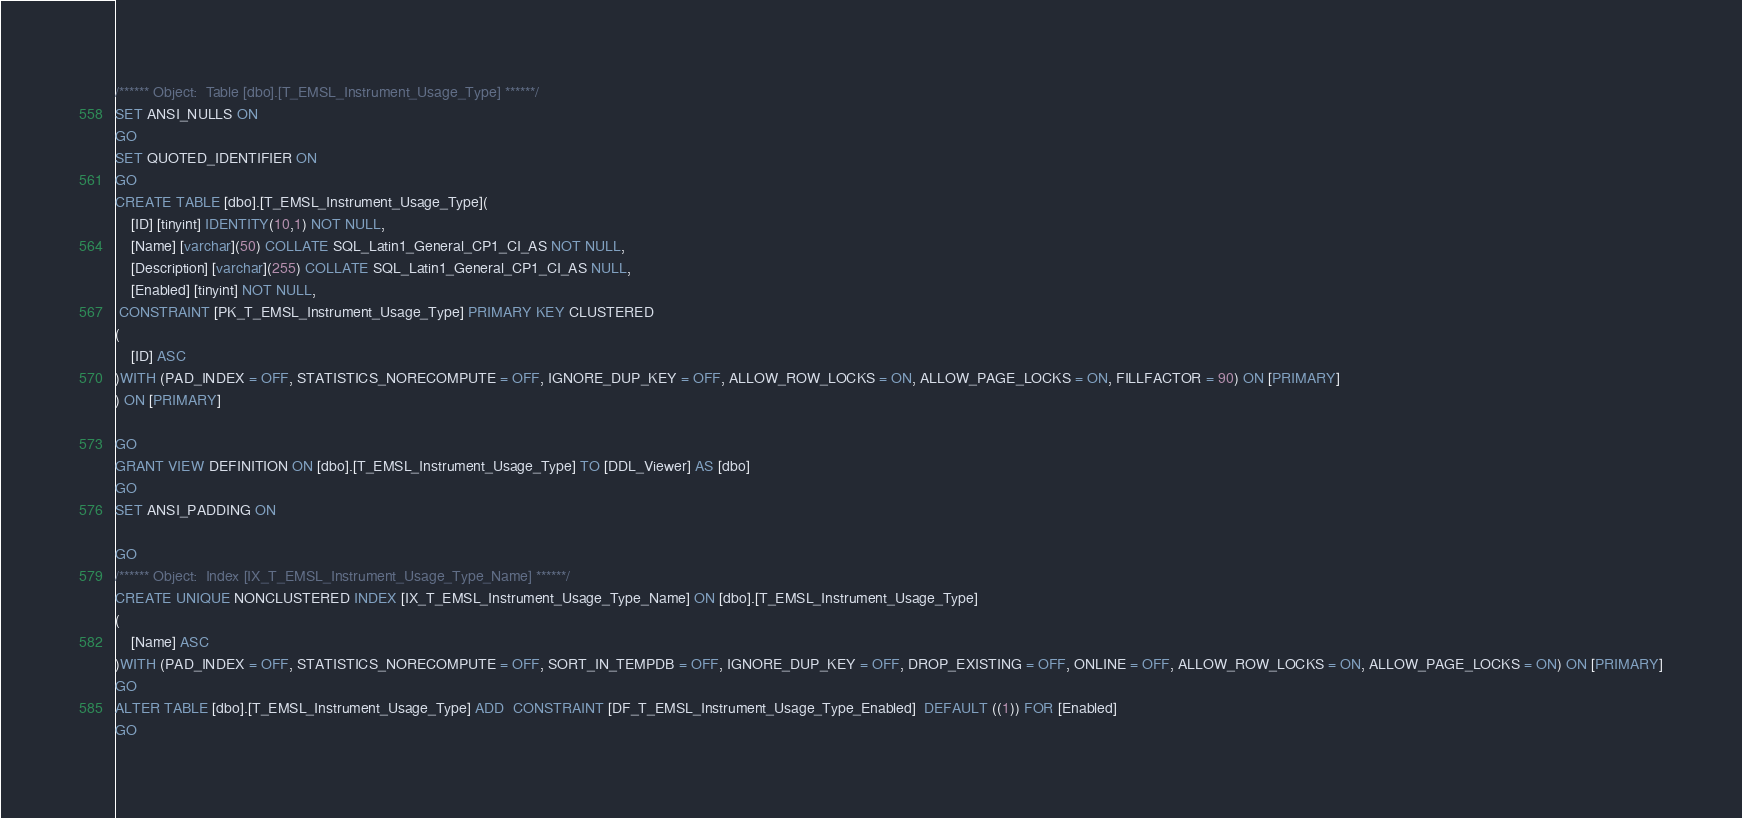Convert code to text. <code><loc_0><loc_0><loc_500><loc_500><_SQL_>/****** Object:  Table [dbo].[T_EMSL_Instrument_Usage_Type] ******/
SET ANSI_NULLS ON
GO
SET QUOTED_IDENTIFIER ON
GO
CREATE TABLE [dbo].[T_EMSL_Instrument_Usage_Type](
	[ID] [tinyint] IDENTITY(10,1) NOT NULL,
	[Name] [varchar](50) COLLATE SQL_Latin1_General_CP1_CI_AS NOT NULL,
	[Description] [varchar](255) COLLATE SQL_Latin1_General_CP1_CI_AS NULL,
	[Enabled] [tinyint] NOT NULL,
 CONSTRAINT [PK_T_EMSL_Instrument_Usage_Type] PRIMARY KEY CLUSTERED 
(
	[ID] ASC
)WITH (PAD_INDEX = OFF, STATISTICS_NORECOMPUTE = OFF, IGNORE_DUP_KEY = OFF, ALLOW_ROW_LOCKS = ON, ALLOW_PAGE_LOCKS = ON, FILLFACTOR = 90) ON [PRIMARY]
) ON [PRIMARY]

GO
GRANT VIEW DEFINITION ON [dbo].[T_EMSL_Instrument_Usage_Type] TO [DDL_Viewer] AS [dbo]
GO
SET ANSI_PADDING ON

GO
/****** Object:  Index [IX_T_EMSL_Instrument_Usage_Type_Name] ******/
CREATE UNIQUE NONCLUSTERED INDEX [IX_T_EMSL_Instrument_Usage_Type_Name] ON [dbo].[T_EMSL_Instrument_Usage_Type]
(
	[Name] ASC
)WITH (PAD_INDEX = OFF, STATISTICS_NORECOMPUTE = OFF, SORT_IN_TEMPDB = OFF, IGNORE_DUP_KEY = OFF, DROP_EXISTING = OFF, ONLINE = OFF, ALLOW_ROW_LOCKS = ON, ALLOW_PAGE_LOCKS = ON) ON [PRIMARY]
GO
ALTER TABLE [dbo].[T_EMSL_Instrument_Usage_Type] ADD  CONSTRAINT [DF_T_EMSL_Instrument_Usage_Type_Enabled]  DEFAULT ((1)) FOR [Enabled]
GO
</code> 